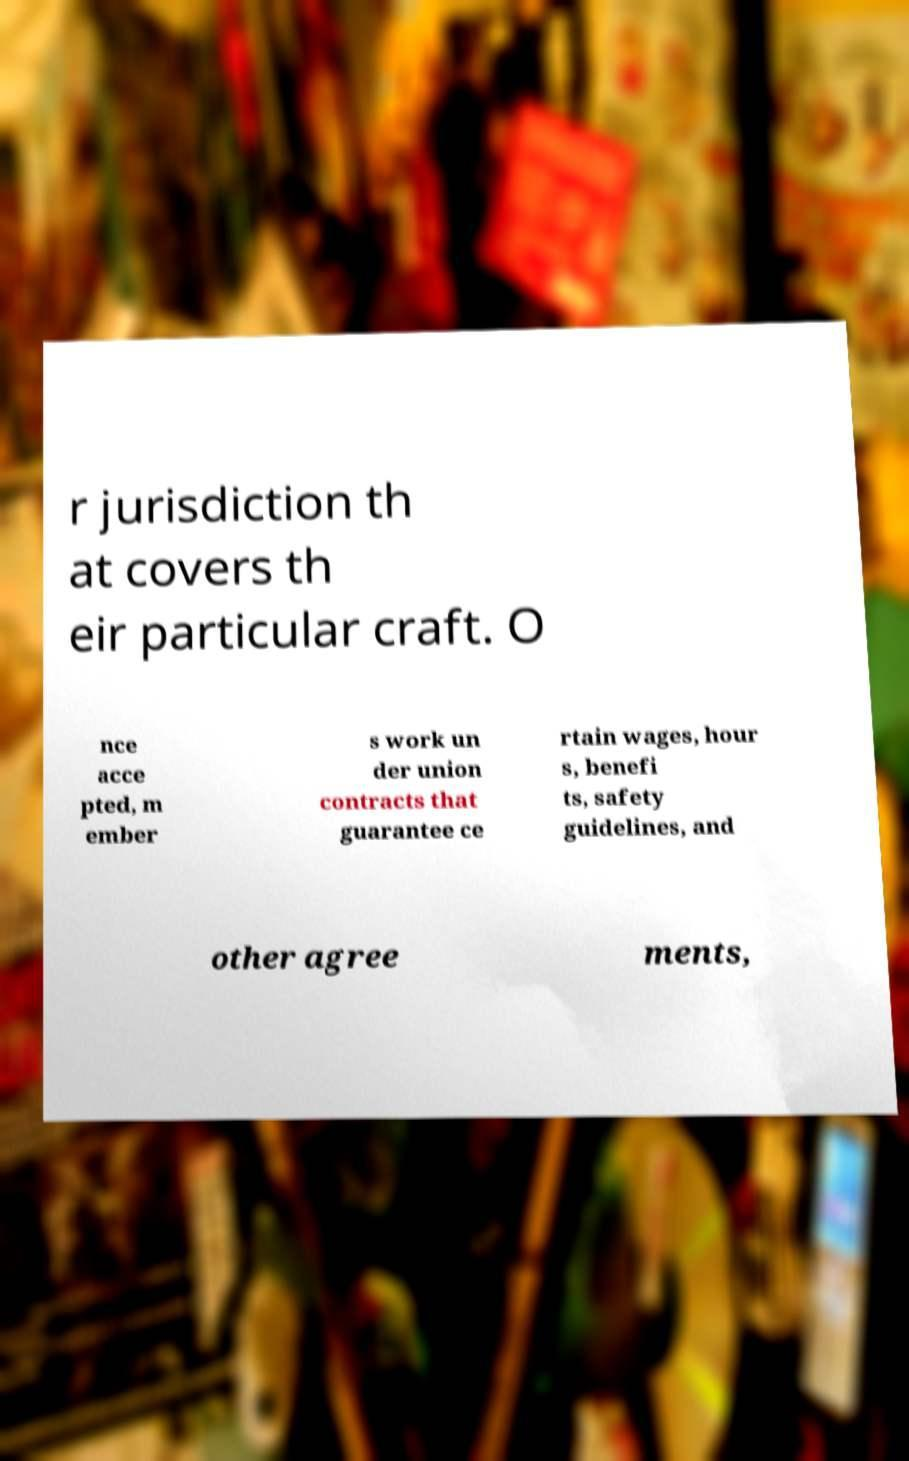What messages or text are displayed in this image? I need them in a readable, typed format. r jurisdiction th at covers th eir particular craft. O nce acce pted, m ember s work un der union contracts that guarantee ce rtain wages, hour s, benefi ts, safety guidelines, and other agree ments, 